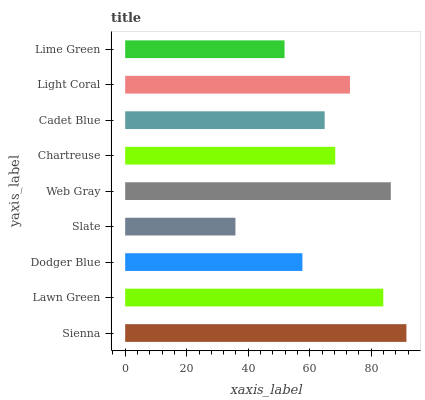Is Slate the minimum?
Answer yes or no. Yes. Is Sienna the maximum?
Answer yes or no. Yes. Is Lawn Green the minimum?
Answer yes or no. No. Is Lawn Green the maximum?
Answer yes or no. No. Is Sienna greater than Lawn Green?
Answer yes or no. Yes. Is Lawn Green less than Sienna?
Answer yes or no. Yes. Is Lawn Green greater than Sienna?
Answer yes or no. No. Is Sienna less than Lawn Green?
Answer yes or no. No. Is Chartreuse the high median?
Answer yes or no. Yes. Is Chartreuse the low median?
Answer yes or no. Yes. Is Lime Green the high median?
Answer yes or no. No. Is Light Coral the low median?
Answer yes or no. No. 